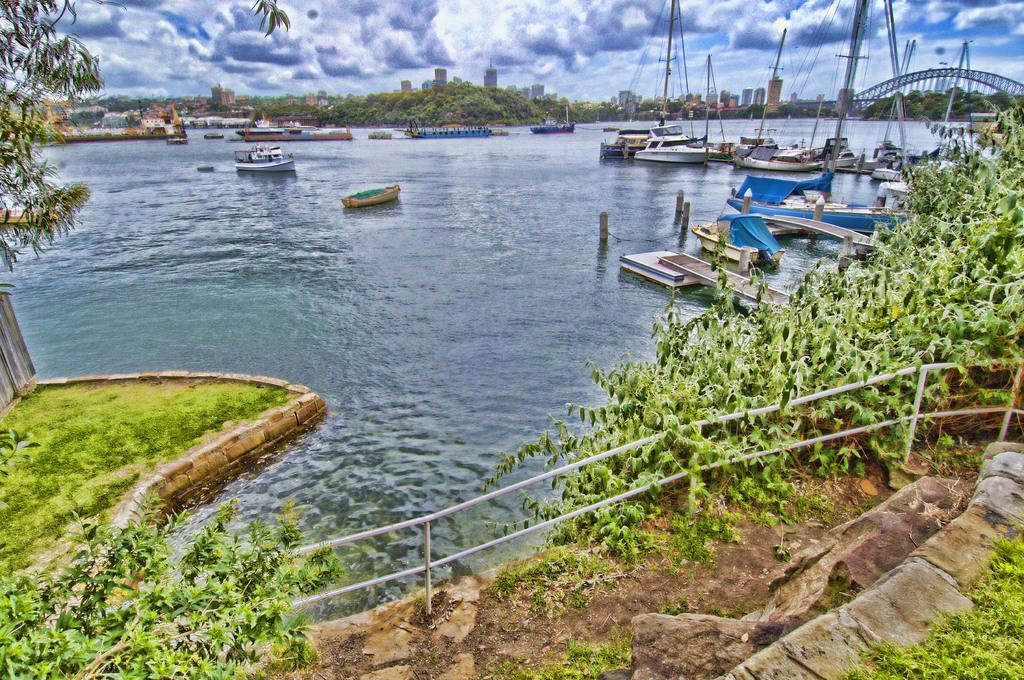What type of vegetation can be seen in the image? There is grass and plants in the image. What objects are made of metal in the image? Iron rods are present in the image. What type of vehicles can be seen in the image? Boats are visible on the water in the image. What type of natural structures are in the image? There are trees in the image. What type of man-made structures are in the image? Buildings are present in the image. What type of transportation infrastructure is in the image? There is a bridge in the image. What part of the natural environment is visible in the background of the image? The sky is visible in the background of the image. What letters are visible on the shirt of the person in the image? There is no person present in the image, so there are no letters visible on a shirt. What type of leaf is present on the tree in the image? There is no specific leaf mentioned or visible in the image; only the trees are mentioned. 